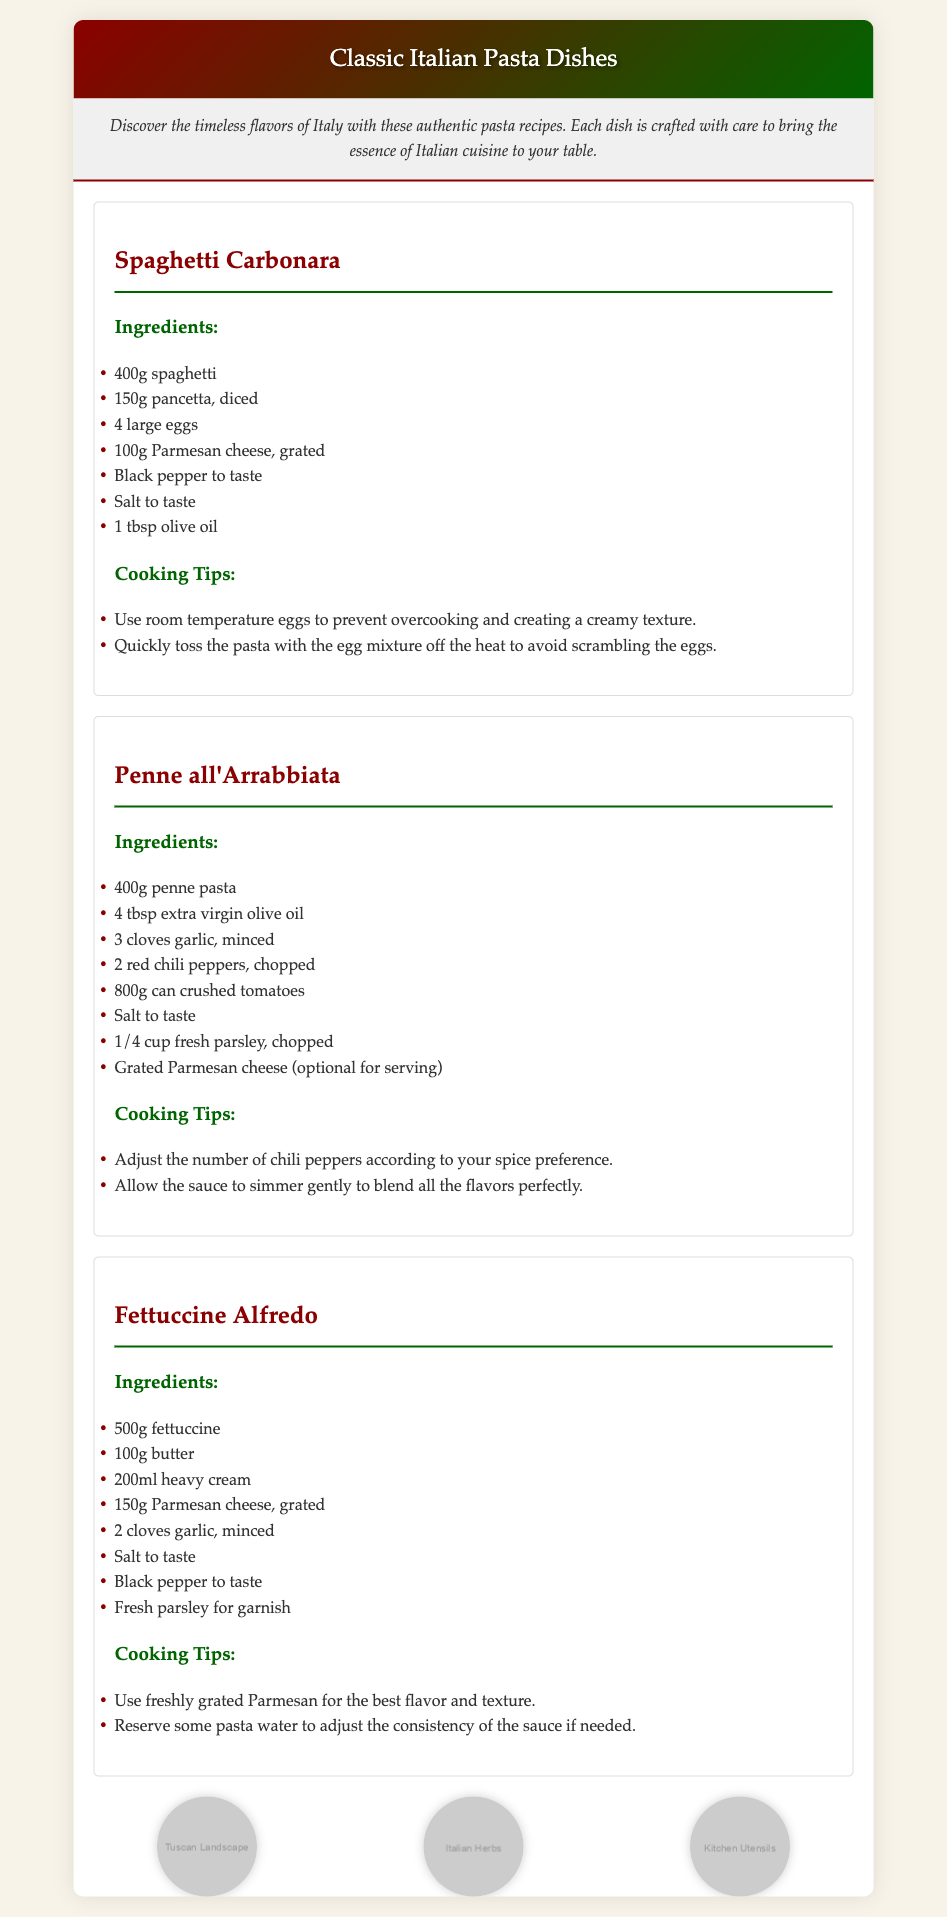what is the main title of the document? The main title is prominently displayed at the top of the document in the header section.
Answer: Classic Italian Pasta Dishes how many recipes are included in the document? The document contains three distinct recipes, each detailed separately.
Answer: 3 what is the first ingredient listed for Spaghetti Carbonara? The ingredients for each recipe are listed in bullet points under the respective recipe headings.
Answer: 400g spaghetti how much olive oil is needed for Penne all'Arrabbiata? The ingredient list for each recipe specifies the required amounts for each component.
Answer: 4 tbsp what is a cooking tip for Fettuccine Alfredo? Each recipe section includes cooking tips that help with preparing the dish.
Answer: Use freshly grated Parmesan for the best flavor and texture what does the design elements section feature? This section displays images with different themes relevant to Italian cooking and culture, enhancing the document's aesthetic.
Answer: Tuscan Landscape, Italian Herbs, Kitchen Utensils which cheese is used in the Spaghetti Carbonara recipe? The ingredients list specifies the type of cheese for each recipe.
Answer: Parmesan cheese what is the total weight of fettuccine needed for the Fettuccine Alfredo recipe? The ingredient for Fettuccine Alfredo indicates the amount required to prepare the dish.
Answer: 500g what color is the header background? The color scheme of the header is described through its gradient design.
Answer: Gradient of dark red and green 